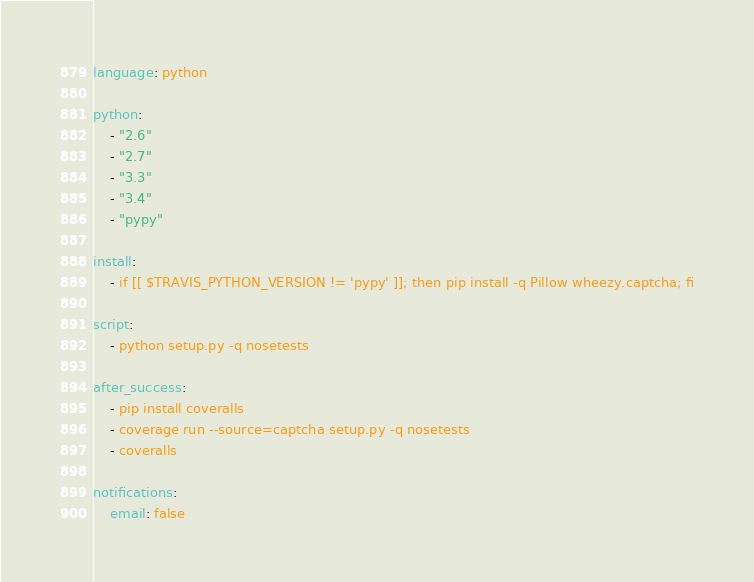Convert code to text. <code><loc_0><loc_0><loc_500><loc_500><_YAML_>language: python

python:
    - "2.6"
    - "2.7"
    - "3.3"
    - "3.4"
    - "pypy"

install:
    - if [[ $TRAVIS_PYTHON_VERSION != 'pypy' ]]; then pip install -q Pillow wheezy.captcha; fi

script:
    - python setup.py -q nosetests

after_success:
    - pip install coveralls
    - coverage run --source=captcha setup.py -q nosetests
    - coveralls

notifications:
    email: false
</code> 